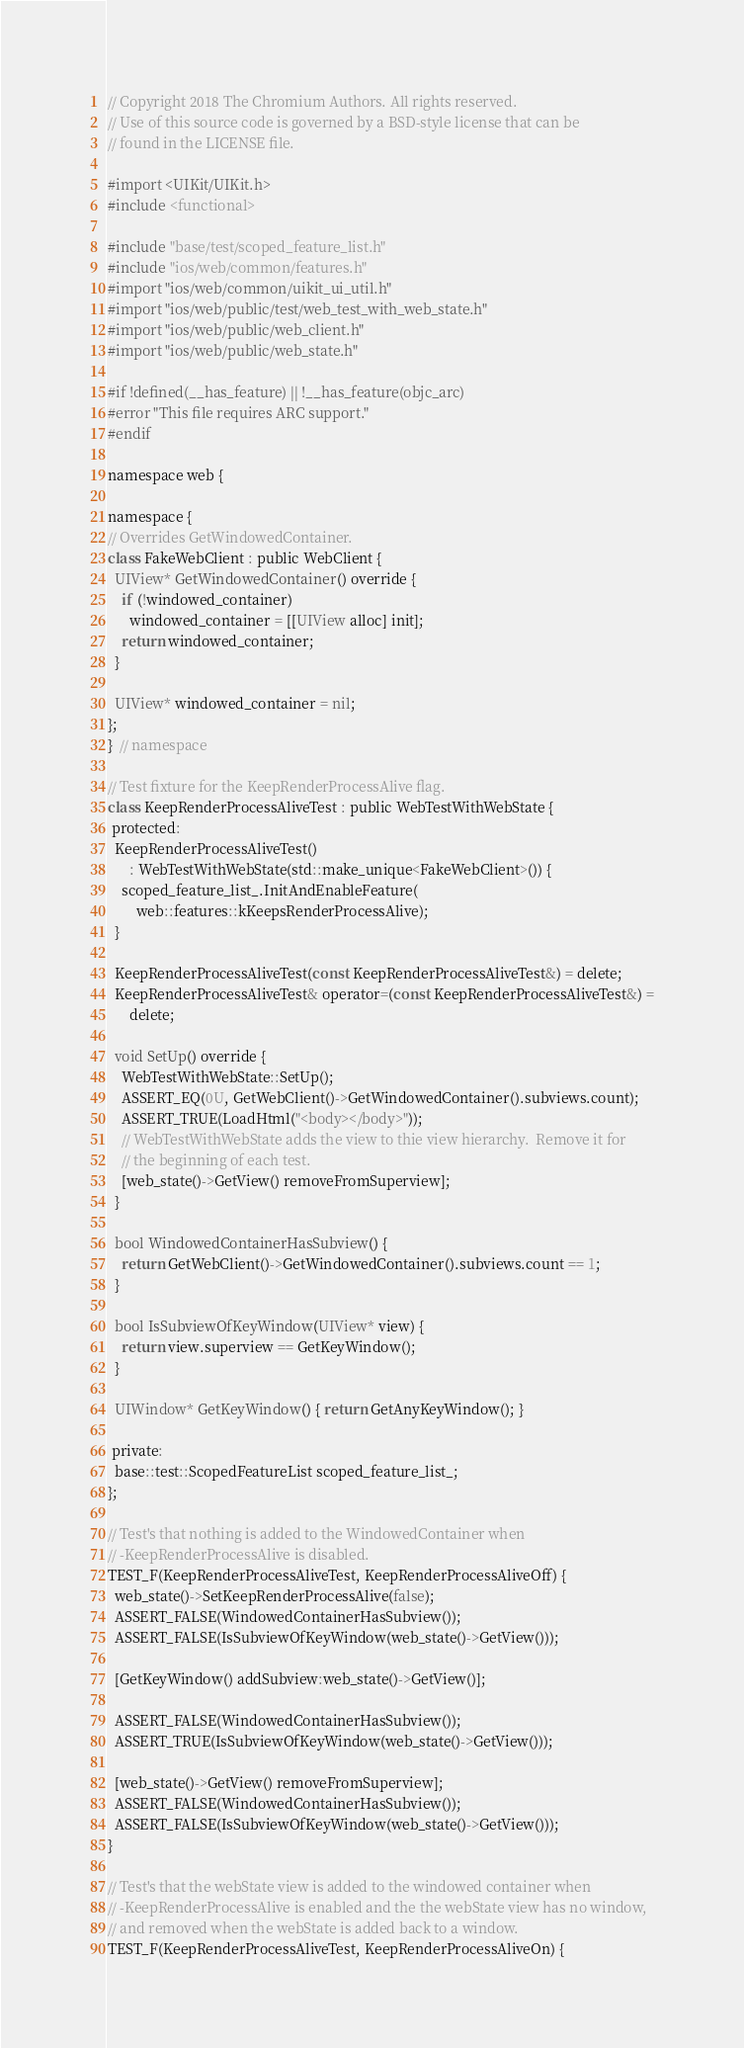<code> <loc_0><loc_0><loc_500><loc_500><_ObjectiveC_>// Copyright 2018 The Chromium Authors. All rights reserved.
// Use of this source code is governed by a BSD-style license that can be
// found in the LICENSE file.

#import <UIKit/UIKit.h>
#include <functional>

#include "base/test/scoped_feature_list.h"
#include "ios/web/common/features.h"
#import "ios/web/common/uikit_ui_util.h"
#import "ios/web/public/test/web_test_with_web_state.h"
#import "ios/web/public/web_client.h"
#import "ios/web/public/web_state.h"

#if !defined(__has_feature) || !__has_feature(objc_arc)
#error "This file requires ARC support."
#endif

namespace web {

namespace {
// Overrides GetWindowedContainer.
class FakeWebClient : public WebClient {
  UIView* GetWindowedContainer() override {
    if (!windowed_container)
      windowed_container = [[UIView alloc] init];
    return windowed_container;
  }

  UIView* windowed_container = nil;
};
}  // namespace

// Test fixture for the KeepRenderProcessAlive flag.
class KeepRenderProcessAliveTest : public WebTestWithWebState {
 protected:
  KeepRenderProcessAliveTest()
      : WebTestWithWebState(std::make_unique<FakeWebClient>()) {
    scoped_feature_list_.InitAndEnableFeature(
        web::features::kKeepsRenderProcessAlive);
  }

  KeepRenderProcessAliveTest(const KeepRenderProcessAliveTest&) = delete;
  KeepRenderProcessAliveTest& operator=(const KeepRenderProcessAliveTest&) =
      delete;

  void SetUp() override {
    WebTestWithWebState::SetUp();
    ASSERT_EQ(0U, GetWebClient()->GetWindowedContainer().subviews.count);
    ASSERT_TRUE(LoadHtml("<body></body>"));
    // WebTestWithWebState adds the view to thie view hierarchy.  Remove it for
    // the beginning of each test.
    [web_state()->GetView() removeFromSuperview];
  }

  bool WindowedContainerHasSubview() {
    return GetWebClient()->GetWindowedContainer().subviews.count == 1;
  }

  bool IsSubviewOfKeyWindow(UIView* view) {
    return view.superview == GetKeyWindow();
  }

  UIWindow* GetKeyWindow() { return GetAnyKeyWindow(); }

 private:
  base::test::ScopedFeatureList scoped_feature_list_;
};

// Test's that nothing is added to the WindowedContainer when
// -KeepRenderProcessAlive is disabled.
TEST_F(KeepRenderProcessAliveTest, KeepRenderProcessAliveOff) {
  web_state()->SetKeepRenderProcessAlive(false);
  ASSERT_FALSE(WindowedContainerHasSubview());
  ASSERT_FALSE(IsSubviewOfKeyWindow(web_state()->GetView()));

  [GetKeyWindow() addSubview:web_state()->GetView()];

  ASSERT_FALSE(WindowedContainerHasSubview());
  ASSERT_TRUE(IsSubviewOfKeyWindow(web_state()->GetView()));

  [web_state()->GetView() removeFromSuperview];
  ASSERT_FALSE(WindowedContainerHasSubview());
  ASSERT_FALSE(IsSubviewOfKeyWindow(web_state()->GetView()));
}

// Test's that the webState view is added to the windowed container when
// -KeepRenderProcessAlive is enabled and the the webState view has no window,
// and removed when the webState is added back to a window.
TEST_F(KeepRenderProcessAliveTest, KeepRenderProcessAliveOn) {</code> 